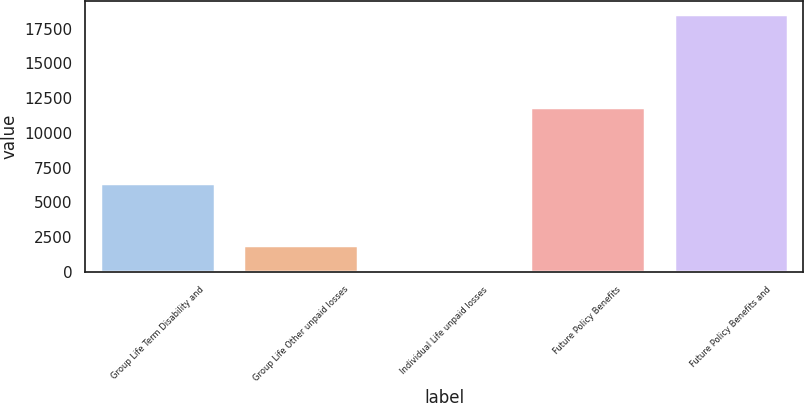Convert chart. <chart><loc_0><loc_0><loc_500><loc_500><bar_chart><fcel>Group Life Term Disability and<fcel>Group Life Other unpaid losses<fcel>Individual Life unpaid losses<fcel>Future Policy Benefits<fcel>Future Policy Benefits and<nl><fcel>6388<fcel>1956.3<fcel>110<fcel>11859<fcel>18573<nl></chart> 